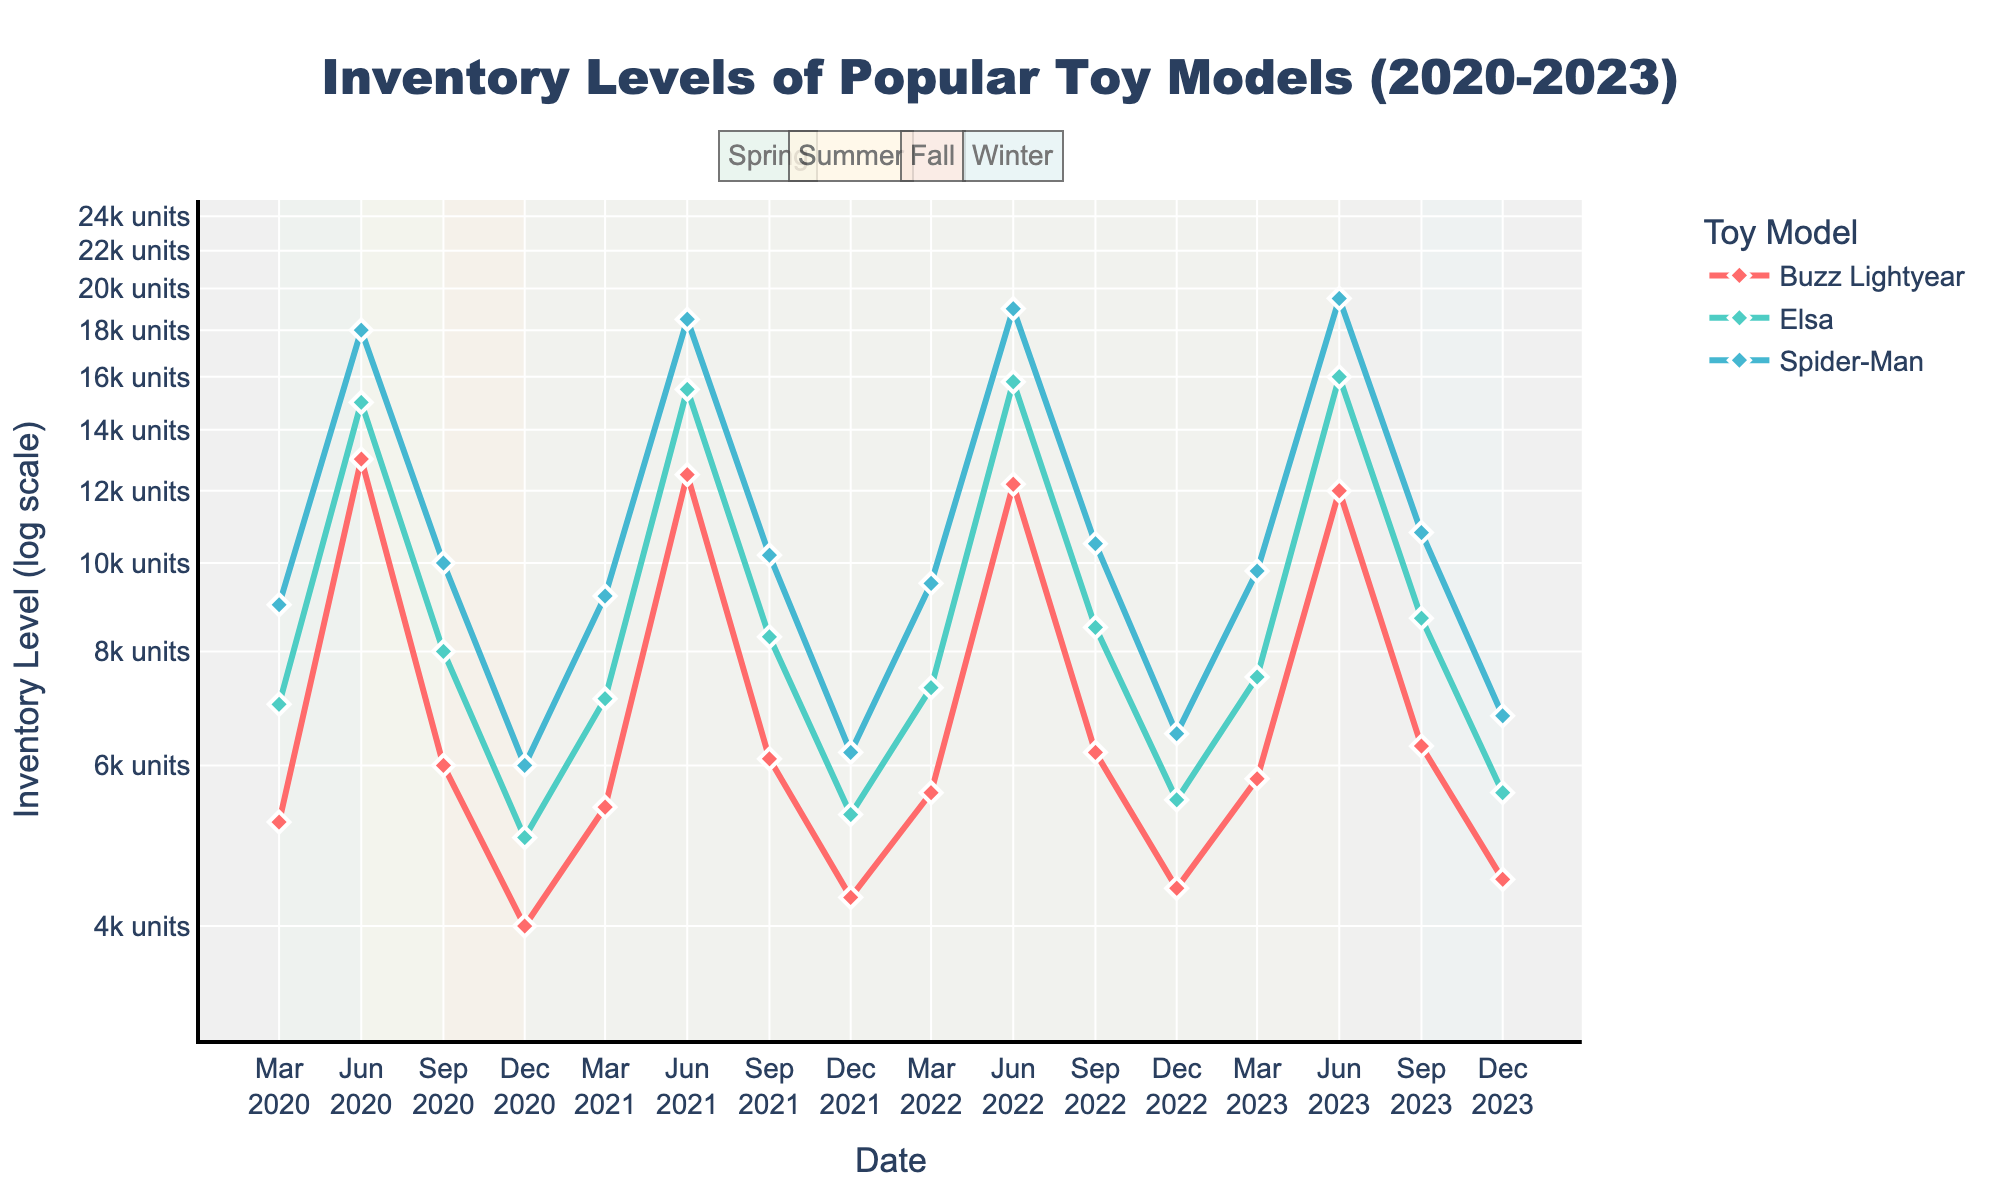What is the title of the figure? The title is usually located at the top of the figure and provides a description of what the figure is about.
Answer: Inventory Levels of Popular Toy Models (2020-2023) What are the labels of the axes? The axis labels are located beside the respective axes. The x-axis is labeled "Date" and the y-axis is labeled "Inventory Level (log scale)".
Answer: Date for x-axis, Inventory Level (log scale) for y-axis How many toy models are represented in the figure? You can count the number of unique lines on the figure, with different colors and legend labels indicating different toy models. There are three unique lines in the legend: Buzz Lightyear, Elsa, and Spider-Man.
Answer: 3 Which season generally has the highest inventory levels? To determine this, observe the inventory levels during each season 'Spring', 'Summer', 'Fall', and 'Winter' from the labeled annotations, and compare the heights of the inventory levels in the log scale. Summer generally has the highest inventory levels.
Answer: Summer For which years is the inventory level data available in the figure? Look for the labels along the x-axis and the extent of the plot range to find out the years for which data is plotted. The data spans from 2020 to 2023.
Answer: 2020 to 2023 What is the inventory level of Elsa during Winter 2020? Locate the point where 'Winter 2020' intersects with the line for Elsa. Reading the y-value from the log scale, you can determine the exact inventory level.
Answer: 5000 units Which toy model had the highest peak inventory level and in which season and year did it occur? Observe the highest points on the plot and identify which toy model’s data series it belongs to, along with the corresponding season and year. The highest inventory level is for Spider-Man in Summer 2023.
Answer: Spider-Man, Summer 2023 Is there an overall increasing or decreasing trend for Buzz Lightyear's inventory levels over the years? Trace the trajectory of Buzz Lightyear's line from 2020 to 2023 for a trend; the line should indicate whether there's an upward or downward trend. Buzz Lightyear shows a slightly decreasing trend over the years.
Answer: Slightly decreasing trend How do the spring inventory levels of Elsa compare across the years 2020 to 2023? Compare the points representing Elsa during Spring from 2020 to 2023, observing their relative heights on the log-scale plot. Elsa's inventory levels show a steady increase from 2020 to 2023 during Spring.
Answer: Steady increase How much higher is Spider-Man's inventory level in Summer 2023 compared to Winter 2023? Identify the inventory levels for Spider-Man in Summer 2023 and Winter 2023 and calculate the difference between them.
Answer: 19,500 - 6,800 units = 12,700 units 